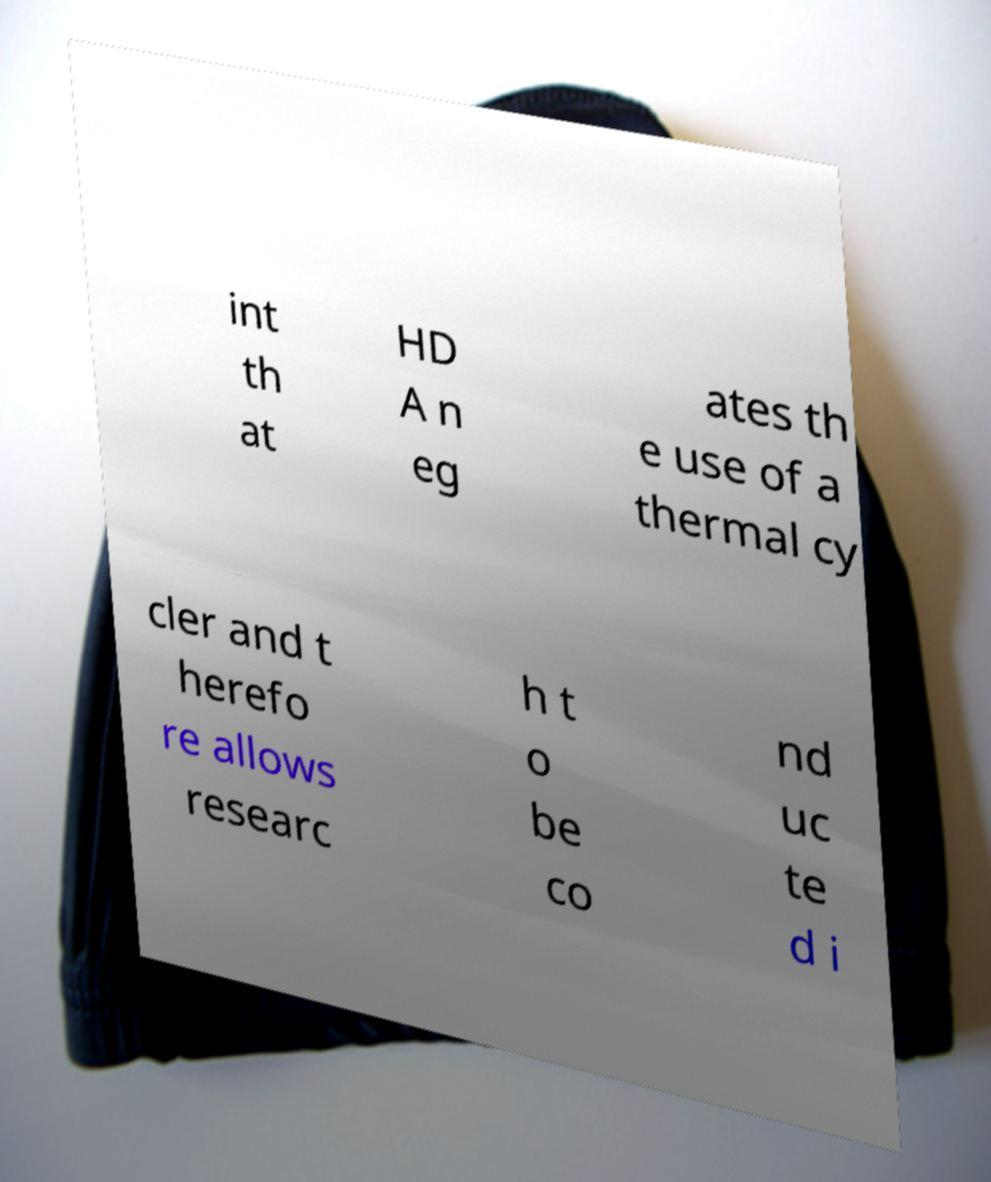Could you extract and type out the text from this image? int th at HD A n eg ates th e use of a thermal cy cler and t herefo re allows researc h t o be co nd uc te d i 